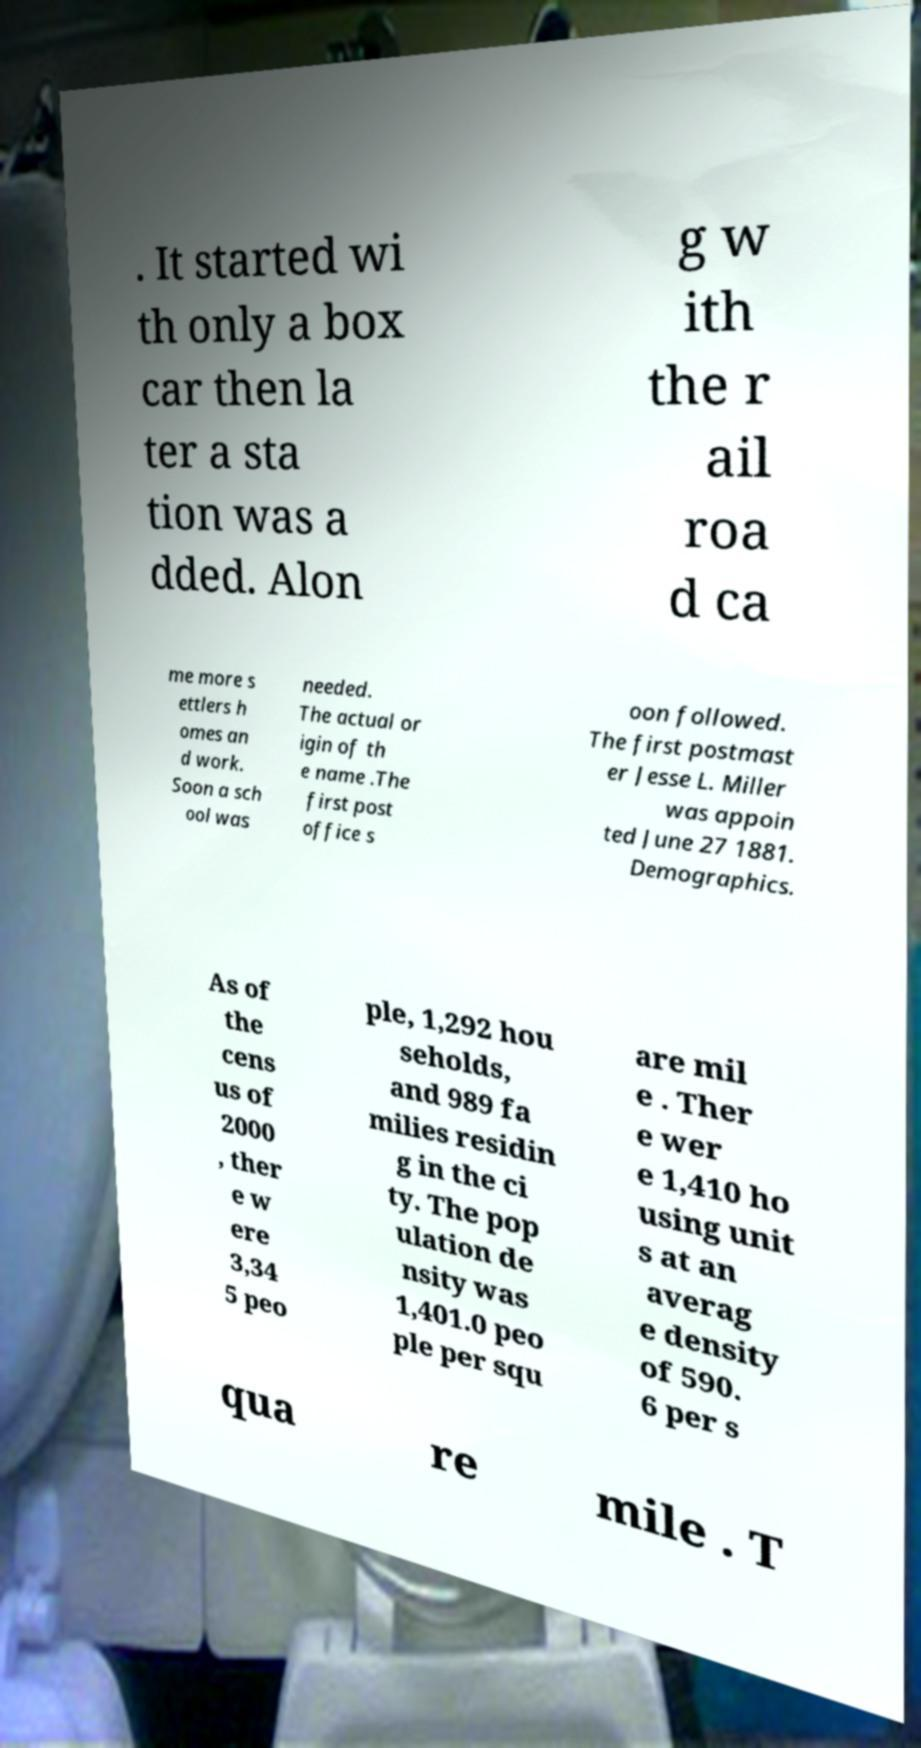Could you assist in decoding the text presented in this image and type it out clearly? . It started wi th only a box car then la ter a sta tion was a dded. Alon g w ith the r ail roa d ca me more s ettlers h omes an d work. Soon a sch ool was needed. The actual or igin of th e name .The first post office s oon followed. The first postmast er Jesse L. Miller was appoin ted June 27 1881. Demographics. As of the cens us of 2000 , ther e w ere 3,34 5 peo ple, 1,292 hou seholds, and 989 fa milies residin g in the ci ty. The pop ulation de nsity was 1,401.0 peo ple per squ are mil e . Ther e wer e 1,410 ho using unit s at an averag e density of 590. 6 per s qua re mile . T 